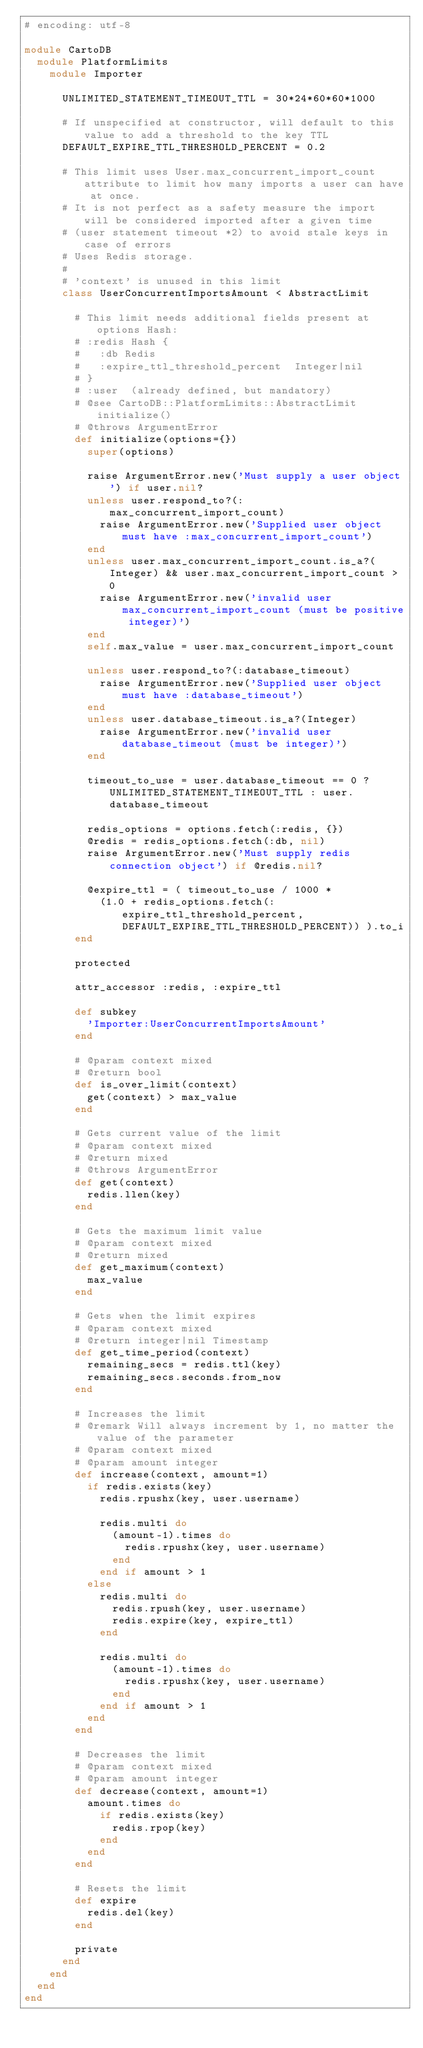Convert code to text. <code><loc_0><loc_0><loc_500><loc_500><_Ruby_># encoding: utf-8

module CartoDB
  module PlatformLimits
    module Importer

      UNLIMITED_STATEMENT_TIMEOUT_TTL = 30*24*60*60*1000

      # If unspecified at constructor, will default to this value to add a threshold to the key TTL
      DEFAULT_EXPIRE_TTL_THRESHOLD_PERCENT = 0.2

      # This limit uses User.max_concurrent_import_count attribute to limit how many imports a user can have at once.
      # It is not perfect as a safety measure the import will be considered imported after a given time
      # (user statement timeout *2) to avoid stale keys in case of errors
      # Uses Redis storage.
      #
      # 'context' is unused in this limit
      class UserConcurrentImportsAmount < AbstractLimit

        # This limit needs additional fields present at options Hash:
        # :redis Hash {
        #   :db Redis
        #   :expire_ttl_threshold_percent  Integer|nil
        # }
        # :user  (already defined, but mandatory)
        # @see CartoDB::PlatformLimits::AbstractLimit initialize()
        # @throws ArgumentError
        def initialize(options={})
          super(options)

          raise ArgumentError.new('Must supply a user object') if user.nil?
          unless user.respond_to?(:max_concurrent_import_count)
            raise ArgumentError.new('Supplied user object must have :max_concurrent_import_count')
          end
          unless user.max_concurrent_import_count.is_a?(Integer) && user.max_concurrent_import_count > 0
            raise ArgumentError.new('invalid user max_concurrent_import_count (must be positive integer)')
          end
          self.max_value = user.max_concurrent_import_count

          unless user.respond_to?(:database_timeout)
            raise ArgumentError.new('Supplied user object must have :database_timeout')
          end
          unless user.database_timeout.is_a?(Integer)
            raise ArgumentError.new('invalid user database_timeout (must be integer)')
          end

          timeout_to_use = user.database_timeout == 0 ? UNLIMITED_STATEMENT_TIMEOUT_TTL : user.database_timeout

          redis_options = options.fetch(:redis, {})
          @redis = redis_options.fetch(:db, nil)
          raise ArgumentError.new('Must supply redis connection object') if @redis.nil?

          @expire_ttl = ( timeout_to_use / 1000 *
            (1.0 + redis_options.fetch(:expire_ttl_threshold_percent, DEFAULT_EXPIRE_TTL_THRESHOLD_PERCENT)) ).to_i
        end

        protected

        attr_accessor :redis, :expire_ttl

        def subkey
          'Importer:UserConcurrentImportsAmount'
        end

        # @param context mixed
        # @return bool
        def is_over_limit(context)
          get(context) > max_value
        end

        # Gets current value of the limit
        # @param context mixed
        # @return mixed
        # @throws ArgumentError
        def get(context)
          redis.llen(key)
        end

        # Gets the maximum limit value
        # @param context mixed
        # @return mixed
        def get_maximum(context)
          max_value
        end

        # Gets when the limit expires
        # @param context mixed
        # @return integer|nil Timestamp
        def get_time_period(context)
          remaining_secs = redis.ttl(key)
          remaining_secs.seconds.from_now
        end

        # Increases the limit
        # @remark Will always increment by 1, no matter the value of the parameter
        # @param context mixed
        # @param amount integer
        def increase(context, amount=1)
          if redis.exists(key)
            redis.rpushx(key, user.username)

            redis.multi do
              (amount-1).times do
                redis.rpushx(key, user.username)
              end
            end if amount > 1
          else
            redis.multi do
              redis.rpush(key, user.username)
              redis.expire(key, expire_ttl)
            end

            redis.multi do
              (amount-1).times do
                redis.rpushx(key, user.username)
              end
            end if amount > 1
          end
        end

        # Decreases the limit
        # @param context mixed
        # @param amount integer
        def decrease(context, amount=1)
          amount.times do
            if redis.exists(key)
              redis.rpop(key)
            end
          end
        end

        # Resets the limit
        def expire
          redis.del(key)
        end

        private
      end
    end
  end
end
</code> 